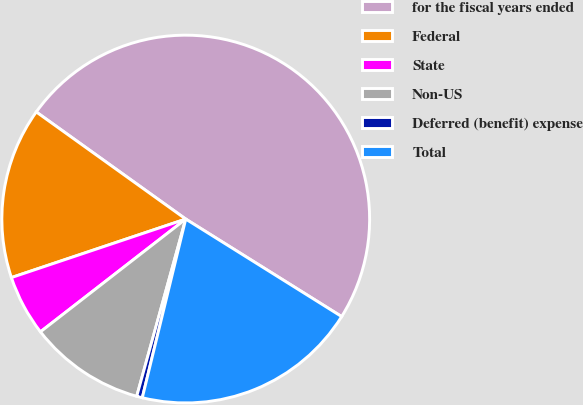Convert chart. <chart><loc_0><loc_0><loc_500><loc_500><pie_chart><fcel>for the fiscal years ended<fcel>Federal<fcel>State<fcel>Non-US<fcel>Deferred (benefit) expense<fcel>Total<nl><fcel>49.0%<fcel>15.05%<fcel>5.35%<fcel>10.2%<fcel>0.5%<fcel>19.9%<nl></chart> 